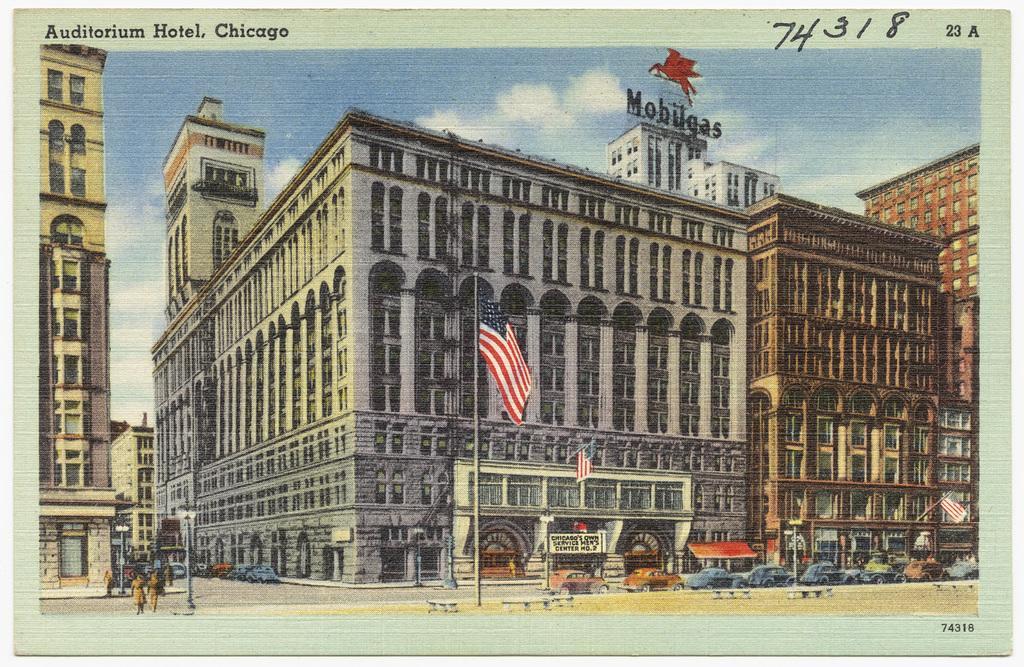How would you summarize this image in a sentence or two? In this picture I can see a poster, there are vehicles on the road, there are boards, flags, there are buildings, and in the background there is the sky and there are words and numbers on the poster. 